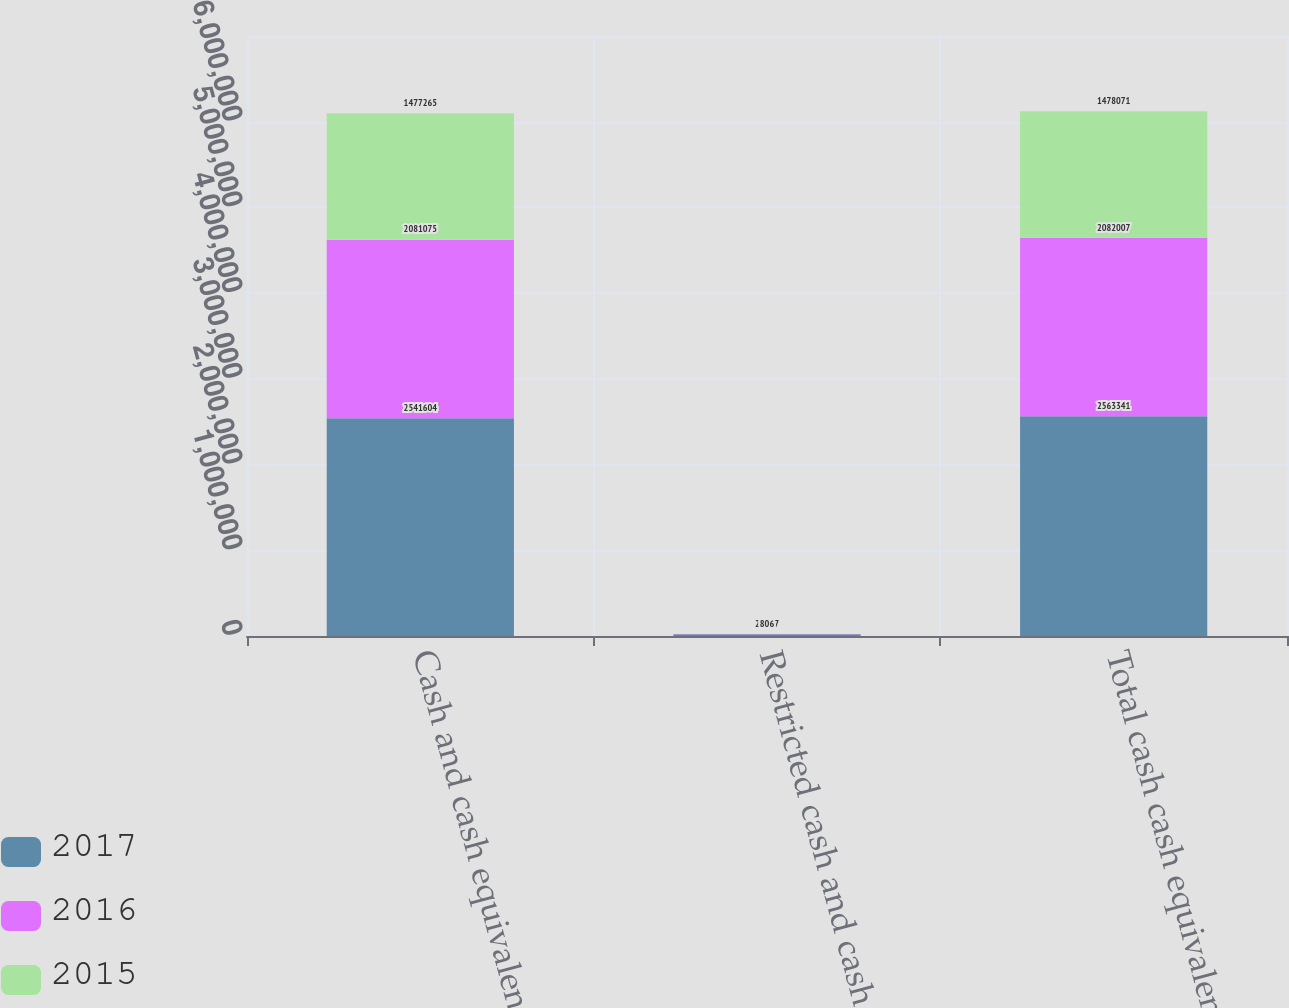Convert chart. <chart><loc_0><loc_0><loc_500><loc_500><stacked_bar_chart><ecel><fcel>Cash and cash equivalents<fcel>Restricted cash and cash<fcel>Total cash cash equivalents<nl><fcel>2017<fcel>2.5416e+06<fcel>21737<fcel>2.56334e+06<nl><fcel>2016<fcel>2.08108e+06<fcel>932<fcel>2.08201e+06<nl><fcel>2015<fcel>1.47726e+06<fcel>806<fcel>1.47807e+06<nl></chart> 